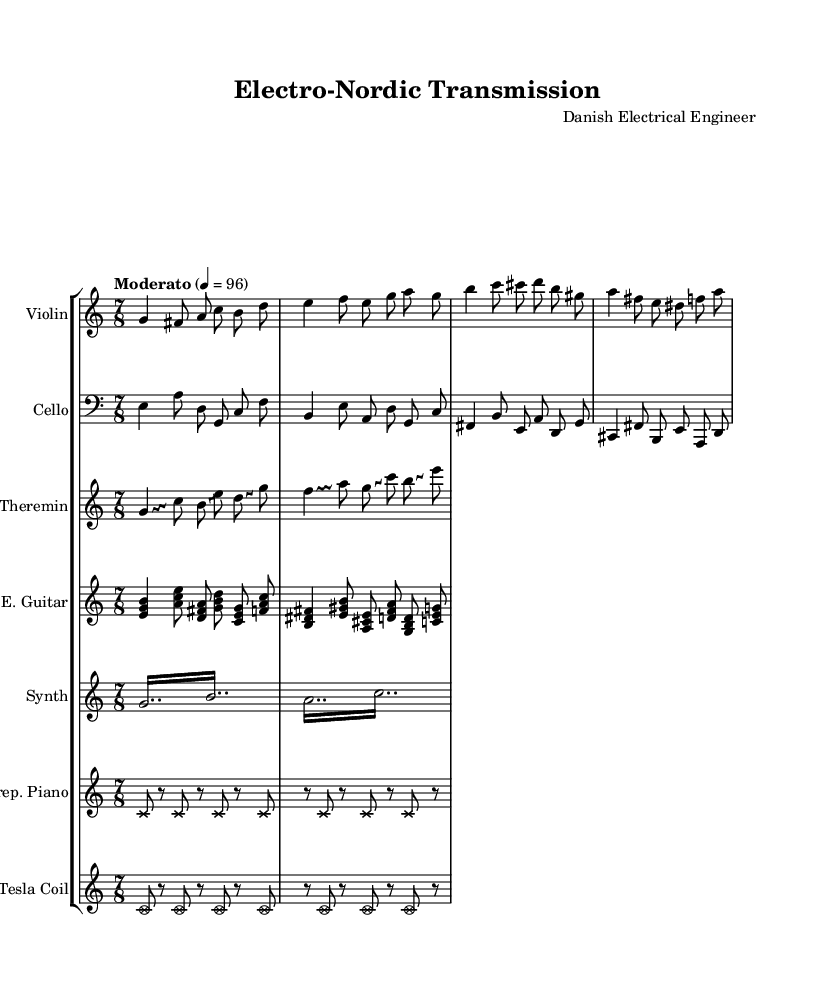What is the time signature of this music? The time signature is indicated at the beginning of the score as 7/8, which means there are seven eighth notes per measure.
Answer: 7/8 What is the tempo marking of this symphony? The tempo marking is indicated in the score. It states "Moderato" with a metronome marking of 4 equals 96 beats per minute, meaning the piece should be played at a moderate speed at this specified tempo.
Answer: Moderato, 4 = 96 How many instruments are used in this composition? The score includes six distinct staves for different instruments: Violin, Cello, Theremin, Electric Guitar, Synth, Prepared Piano, and Tesla Coil. Counting these gives a total of seven instruments used in this symphony.
Answer: Seven Which instrument plays glissando notes in the score? Glissando is indicated specifically for the Theremin part, which is marked with an override for the Glissando style, applying it to several notes. This style allows for sliding between pitches.
Answer: Theremin What type of notation is used for the Prepared Piano? The notation for the Prepared Piano features cross note heads, indicating the use of unconventional techniques, typical for prepared piano music where objects are placed on or between the strings.
Answer: Cross note heads What is a unique instrument featured in this symphony that is not traditional? The score features a Tesla Coil, which produces sounds using high-voltage electric discharges, representing an unconventional choice for a symphonic work.
Answer: Tesla Coil 